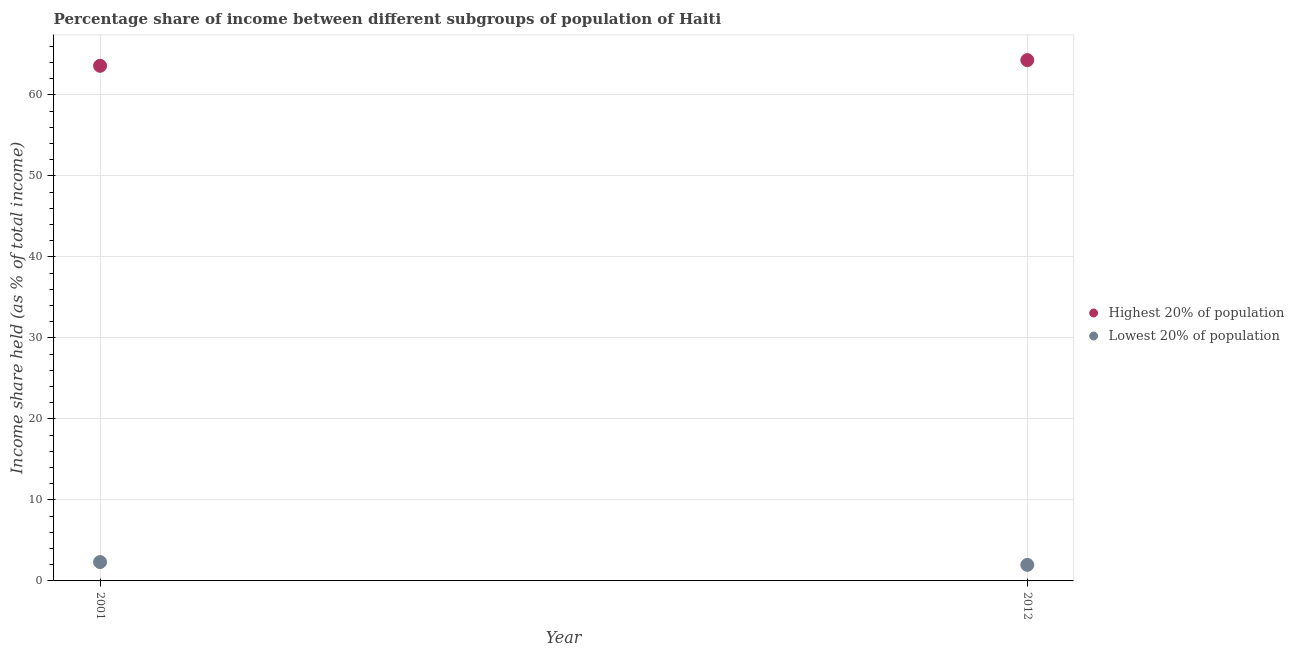Is the number of dotlines equal to the number of legend labels?
Keep it short and to the point. Yes. What is the income share held by highest 20% of the population in 2001?
Your answer should be compact. 63.59. Across all years, what is the maximum income share held by highest 20% of the population?
Make the answer very short. 64.29. Across all years, what is the minimum income share held by highest 20% of the population?
Your answer should be compact. 63.59. In which year was the income share held by lowest 20% of the population maximum?
Provide a succinct answer. 2001. In which year was the income share held by highest 20% of the population minimum?
Your response must be concise. 2001. What is the total income share held by lowest 20% of the population in the graph?
Offer a very short reply. 4.31. What is the difference between the income share held by lowest 20% of the population in 2001 and that in 2012?
Your answer should be compact. 0.35. What is the difference between the income share held by lowest 20% of the population in 2001 and the income share held by highest 20% of the population in 2012?
Offer a very short reply. -61.96. What is the average income share held by lowest 20% of the population per year?
Provide a succinct answer. 2.16. In the year 2012, what is the difference between the income share held by lowest 20% of the population and income share held by highest 20% of the population?
Provide a short and direct response. -62.31. In how many years, is the income share held by highest 20% of the population greater than 32 %?
Give a very brief answer. 2. What is the ratio of the income share held by lowest 20% of the population in 2001 to that in 2012?
Offer a terse response. 1.18. Does the income share held by lowest 20% of the population monotonically increase over the years?
Your answer should be compact. No. Is the income share held by highest 20% of the population strictly greater than the income share held by lowest 20% of the population over the years?
Offer a very short reply. Yes. Is the income share held by lowest 20% of the population strictly less than the income share held by highest 20% of the population over the years?
Make the answer very short. Yes. How many dotlines are there?
Offer a terse response. 2. How many years are there in the graph?
Offer a very short reply. 2. What is the difference between two consecutive major ticks on the Y-axis?
Your response must be concise. 10. Are the values on the major ticks of Y-axis written in scientific E-notation?
Provide a short and direct response. No. Where does the legend appear in the graph?
Ensure brevity in your answer.  Center right. How many legend labels are there?
Keep it short and to the point. 2. What is the title of the graph?
Provide a short and direct response. Percentage share of income between different subgroups of population of Haiti. Does "Methane" appear as one of the legend labels in the graph?
Provide a succinct answer. No. What is the label or title of the Y-axis?
Your answer should be compact. Income share held (as % of total income). What is the Income share held (as % of total income) of Highest 20% of population in 2001?
Your answer should be very brief. 63.59. What is the Income share held (as % of total income) of Lowest 20% of population in 2001?
Your answer should be compact. 2.33. What is the Income share held (as % of total income) of Highest 20% of population in 2012?
Give a very brief answer. 64.29. What is the Income share held (as % of total income) in Lowest 20% of population in 2012?
Your response must be concise. 1.98. Across all years, what is the maximum Income share held (as % of total income) of Highest 20% of population?
Offer a very short reply. 64.29. Across all years, what is the maximum Income share held (as % of total income) in Lowest 20% of population?
Your response must be concise. 2.33. Across all years, what is the minimum Income share held (as % of total income) of Highest 20% of population?
Your answer should be compact. 63.59. Across all years, what is the minimum Income share held (as % of total income) of Lowest 20% of population?
Keep it short and to the point. 1.98. What is the total Income share held (as % of total income) of Highest 20% of population in the graph?
Provide a short and direct response. 127.88. What is the total Income share held (as % of total income) in Lowest 20% of population in the graph?
Offer a terse response. 4.31. What is the difference between the Income share held (as % of total income) in Highest 20% of population in 2001 and that in 2012?
Your answer should be compact. -0.7. What is the difference between the Income share held (as % of total income) of Highest 20% of population in 2001 and the Income share held (as % of total income) of Lowest 20% of population in 2012?
Provide a succinct answer. 61.61. What is the average Income share held (as % of total income) in Highest 20% of population per year?
Give a very brief answer. 63.94. What is the average Income share held (as % of total income) in Lowest 20% of population per year?
Provide a succinct answer. 2.15. In the year 2001, what is the difference between the Income share held (as % of total income) of Highest 20% of population and Income share held (as % of total income) of Lowest 20% of population?
Your response must be concise. 61.26. In the year 2012, what is the difference between the Income share held (as % of total income) in Highest 20% of population and Income share held (as % of total income) in Lowest 20% of population?
Offer a very short reply. 62.31. What is the ratio of the Income share held (as % of total income) in Lowest 20% of population in 2001 to that in 2012?
Make the answer very short. 1.18. What is the difference between the highest and the second highest Income share held (as % of total income) of Highest 20% of population?
Keep it short and to the point. 0.7. What is the difference between the highest and the second highest Income share held (as % of total income) of Lowest 20% of population?
Provide a succinct answer. 0.35. What is the difference between the highest and the lowest Income share held (as % of total income) in Lowest 20% of population?
Give a very brief answer. 0.35. 